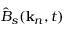Convert formula to latex. <formula><loc_0><loc_0><loc_500><loc_500>\hat { B } _ { s } ( k _ { n } , t )</formula> 